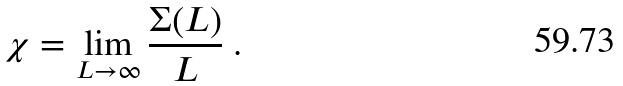Convert formula to latex. <formula><loc_0><loc_0><loc_500><loc_500>\chi = \lim _ { L \to \infty } \frac { \Sigma ( L ) } { L } \ .</formula> 